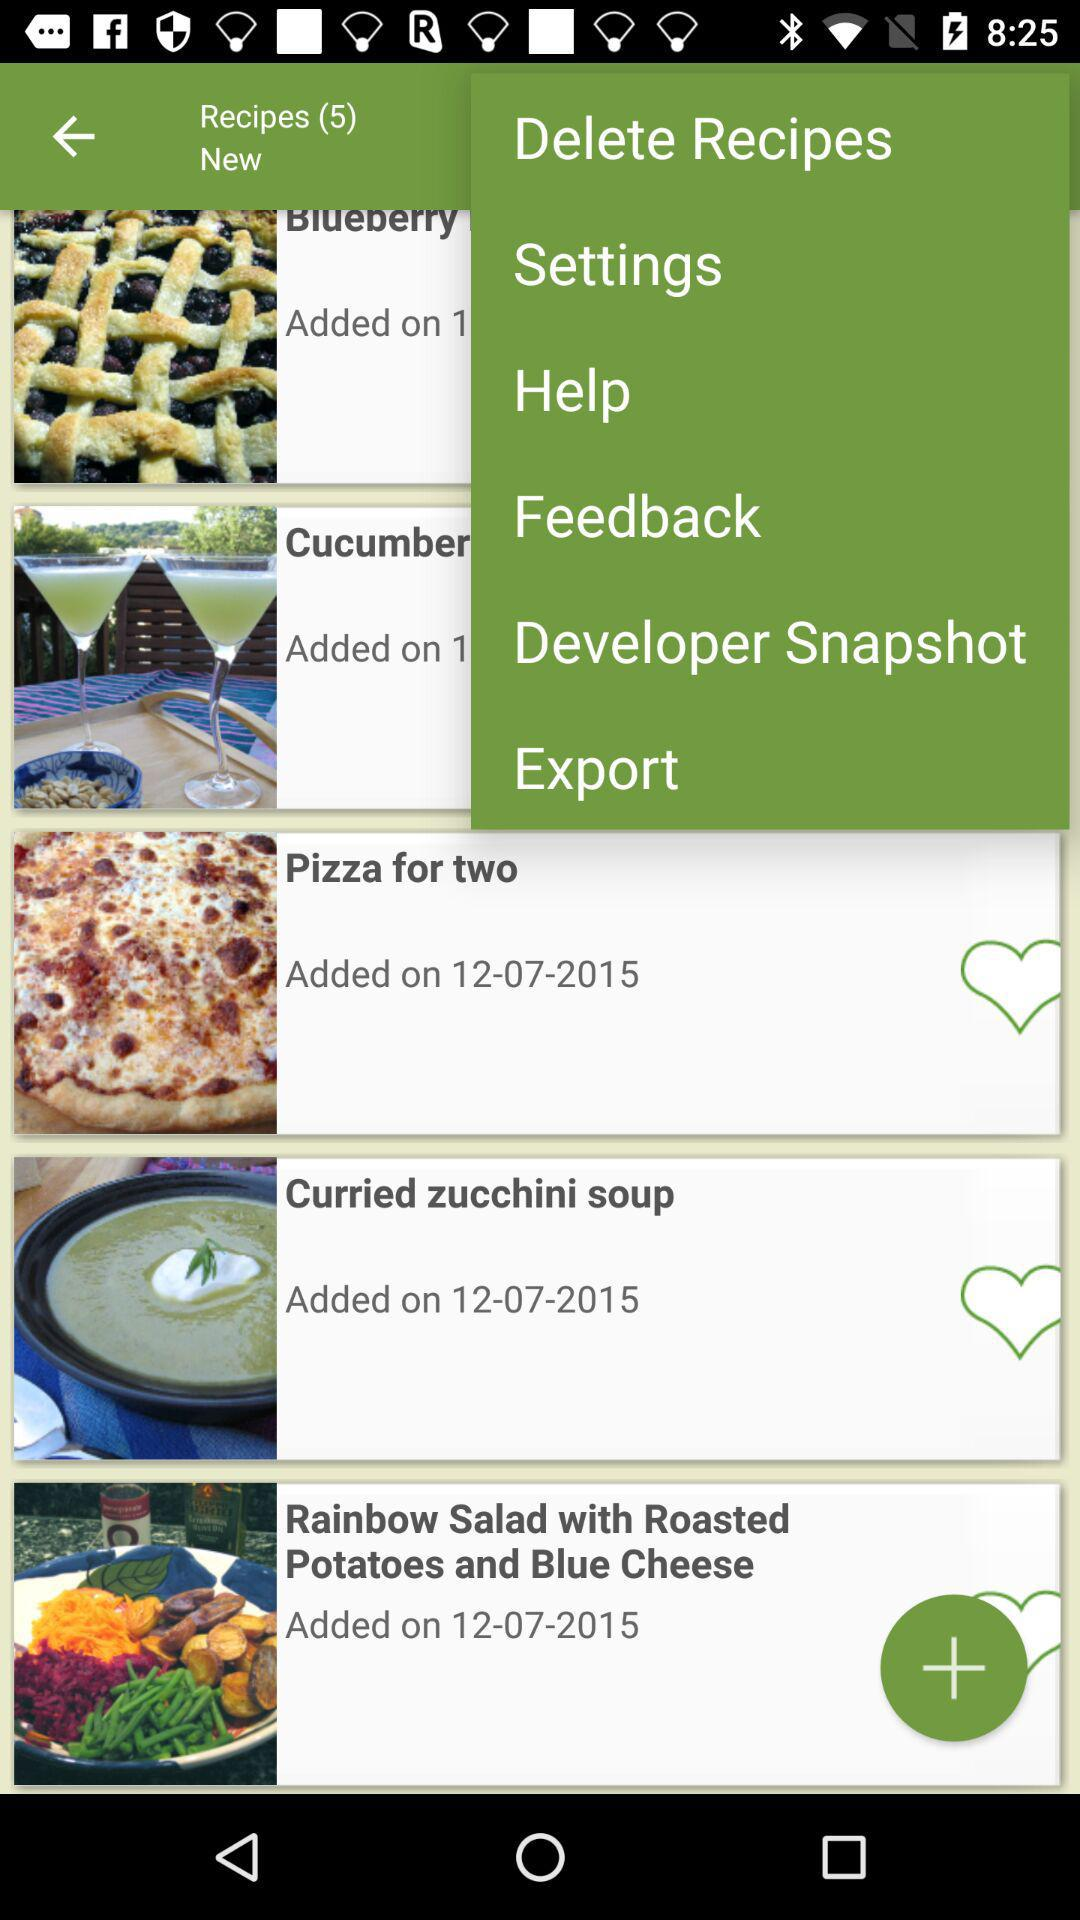On what date was "Pizza for two" added? "Pizza for two" was added on December 7, 2015. 